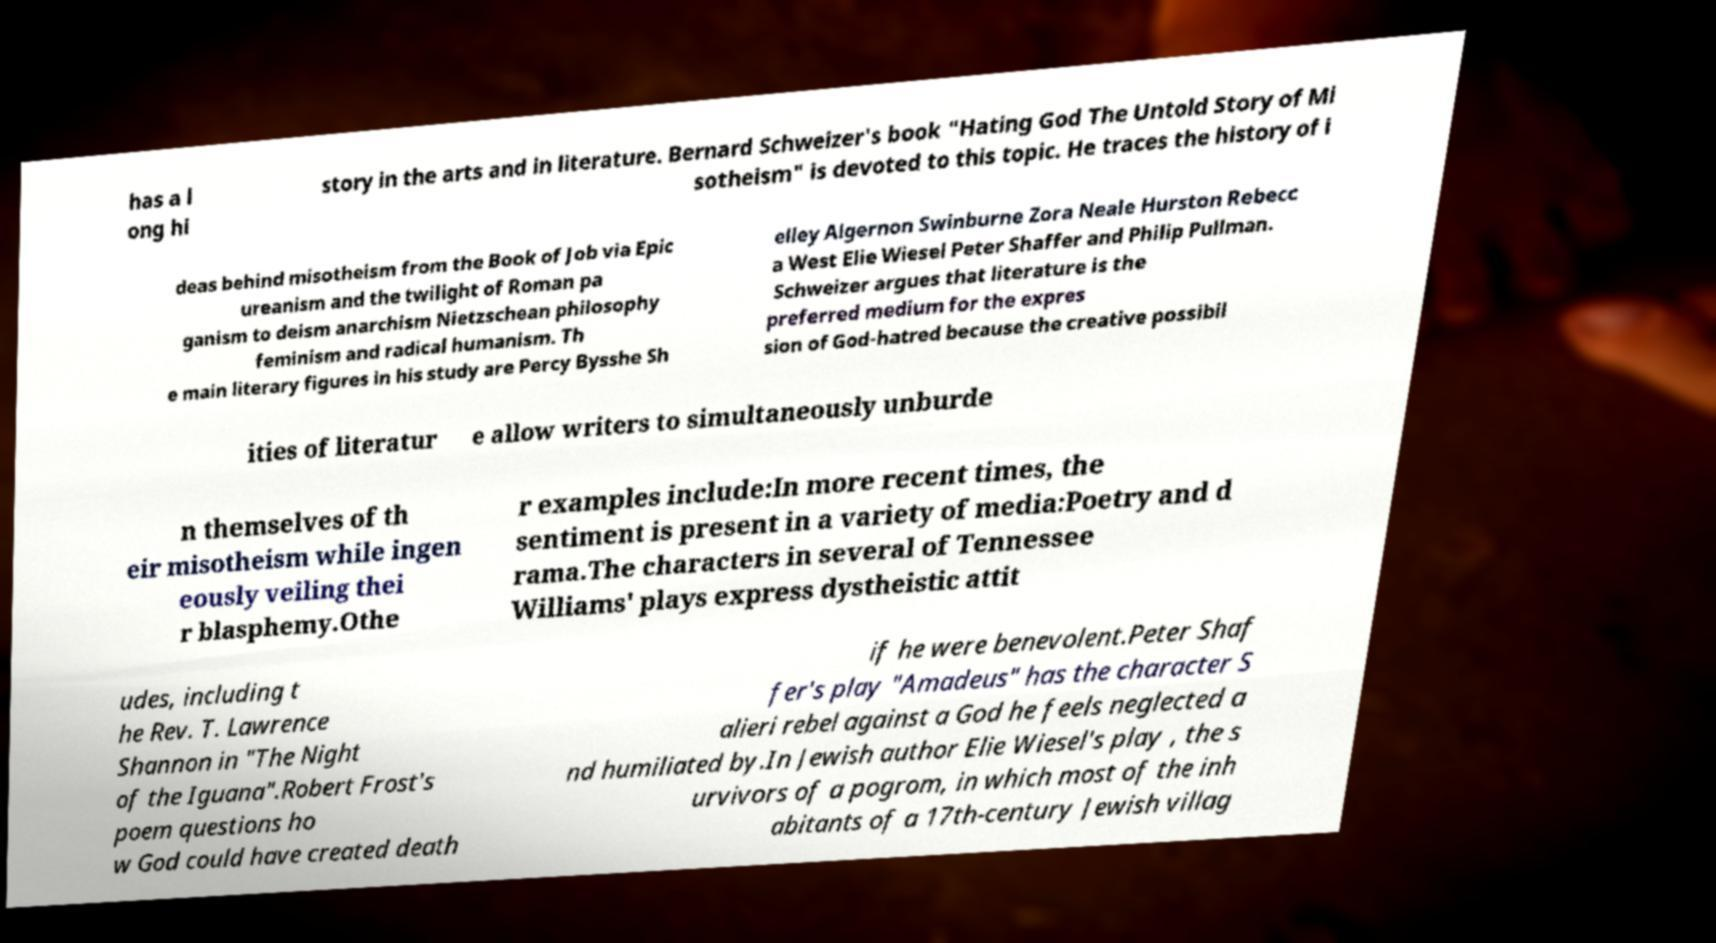Can you read and provide the text displayed in the image?This photo seems to have some interesting text. Can you extract and type it out for me? has a l ong hi story in the arts and in literature. Bernard Schweizer's book "Hating God The Untold Story of Mi sotheism" is devoted to this topic. He traces the history of i deas behind misotheism from the Book of Job via Epic ureanism and the twilight of Roman pa ganism to deism anarchism Nietzschean philosophy feminism and radical humanism. Th e main literary figures in his study are Percy Bysshe Sh elley Algernon Swinburne Zora Neale Hurston Rebecc a West Elie Wiesel Peter Shaffer and Philip Pullman. Schweizer argues that literature is the preferred medium for the expres sion of God-hatred because the creative possibil ities of literatur e allow writers to simultaneously unburde n themselves of th eir misotheism while ingen eously veiling thei r blasphemy.Othe r examples include:In more recent times, the sentiment is present in a variety of media:Poetry and d rama.The characters in several of Tennessee Williams' plays express dystheistic attit udes, including t he Rev. T. Lawrence Shannon in "The Night of the Iguana".Robert Frost's poem questions ho w God could have created death if he were benevolent.Peter Shaf fer's play "Amadeus" has the character S alieri rebel against a God he feels neglected a nd humiliated by.In Jewish author Elie Wiesel's play , the s urvivors of a pogrom, in which most of the inh abitants of a 17th-century Jewish villag 